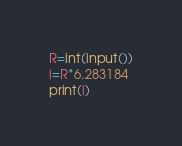<code> <loc_0><loc_0><loc_500><loc_500><_Python_>R=int(input())
i=R*6.283184
print(i)</code> 